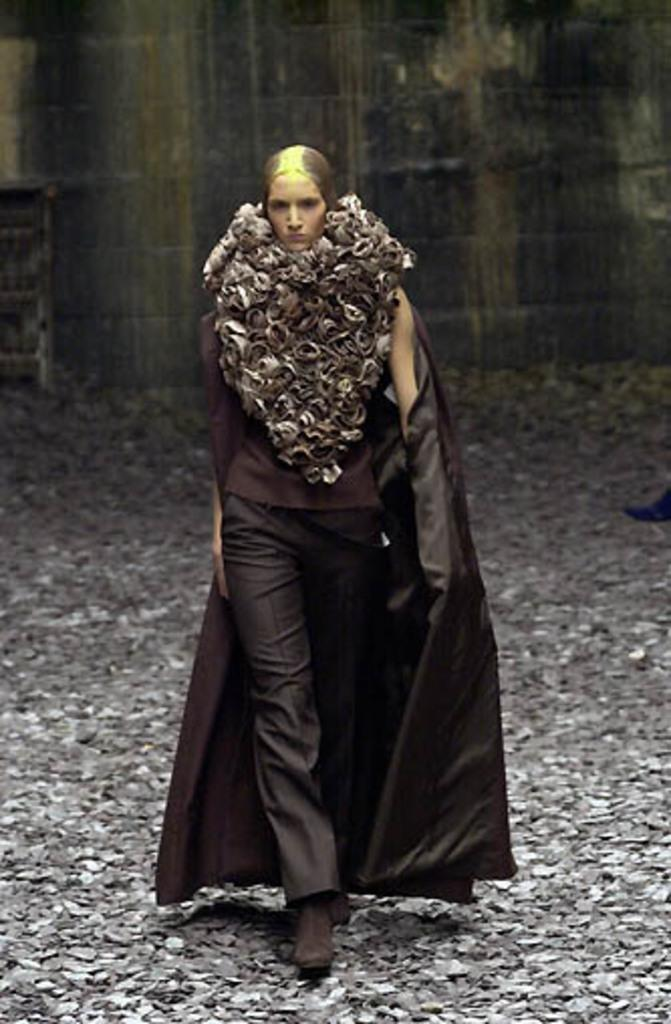Who is the main subject in the image? There is a girl in the image. What is the girl doing in the image? The girl is walking on stones. Can you describe the decorative item the girl is wearing? The girl has a decorative item around her neck. How many dimes can be seen in the image? There are no dimes present in the image. What type of club is the girl holding in the image? There is no club present in the image. 